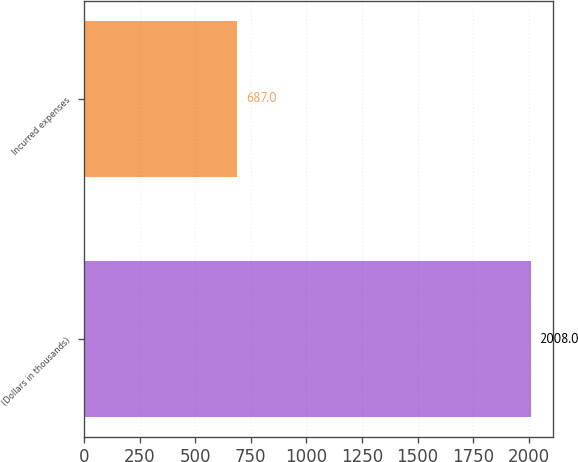<chart> <loc_0><loc_0><loc_500><loc_500><bar_chart><fcel>(Dollars in thousands)<fcel>Incurred expenses<nl><fcel>2008<fcel>687<nl></chart> 